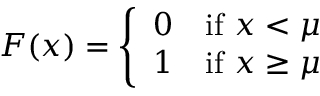Convert formula to latex. <formula><loc_0><loc_0><loc_500><loc_500>F ( x ) = { \left \{ \begin{array} { l l } { 0 } & { { i f } x < \mu } \\ { 1 } & { { i f } x \geq \mu } \end{array} }</formula> 